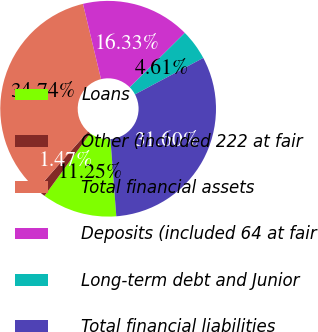Convert chart. <chart><loc_0><loc_0><loc_500><loc_500><pie_chart><fcel>Loans<fcel>Other (included 222 at fair<fcel>Total financial assets<fcel>Deposits (included 64 at fair<fcel>Long-term debt and Junior<fcel>Total financial liabilities<nl><fcel>11.25%<fcel>1.47%<fcel>34.74%<fcel>16.33%<fcel>4.61%<fcel>31.6%<nl></chart> 